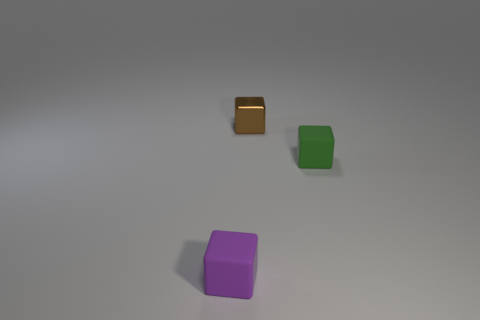Is there anything else that has the same material as the tiny purple object?
Your answer should be compact. Yes. There is a metal object that is the same size as the purple matte block; what is its color?
Provide a succinct answer. Brown. What size is the purple object that is the same material as the tiny green cube?
Make the answer very short. Small. There is a small brown thing that is to the left of the small green matte object; what is it made of?
Keep it short and to the point. Metal. There is a rubber thing in front of the small matte block that is right of the rubber object to the left of the green matte thing; what shape is it?
Ensure brevity in your answer.  Cube. How many things are tiny cubes or small rubber blocks that are in front of the tiny green object?
Your response must be concise. 3. How many objects are small rubber cubes in front of the small green object or things on the right side of the metallic cube?
Your response must be concise. 2. There is a tiny brown block; are there any small blocks in front of it?
Ensure brevity in your answer.  Yes. What color is the matte cube on the right side of the tiny rubber cube that is in front of the tiny object right of the tiny brown block?
Ensure brevity in your answer.  Green. Is the shape of the brown metallic object the same as the green object?
Ensure brevity in your answer.  Yes. 